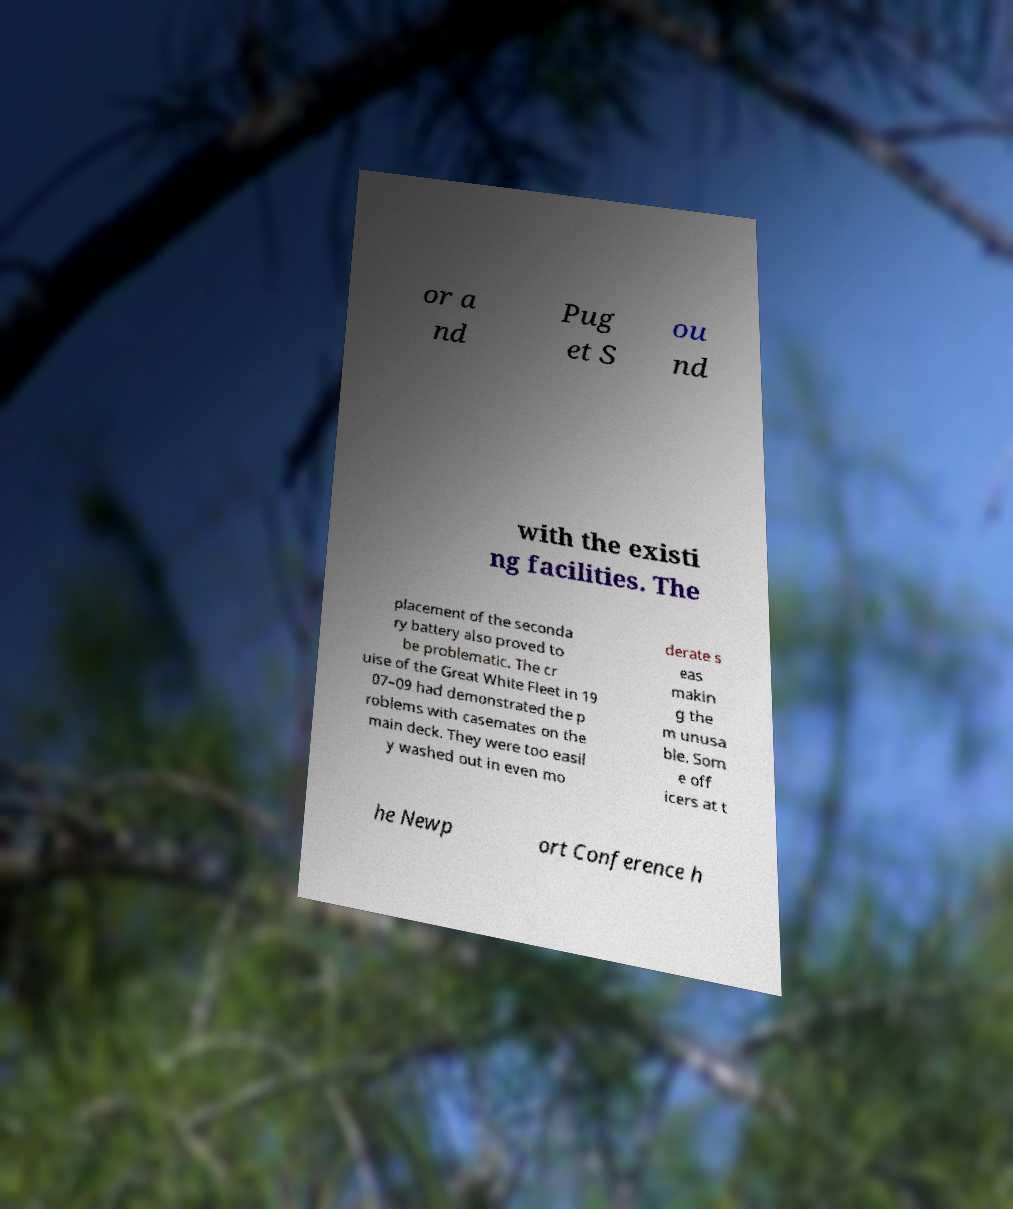I need the written content from this picture converted into text. Can you do that? or a nd Pug et S ou nd with the existi ng facilities. The placement of the seconda ry battery also proved to be problematic. The cr uise of the Great White Fleet in 19 07–09 had demonstrated the p roblems with casemates on the main deck. They were too easil y washed out in even mo derate s eas makin g the m unusa ble. Som e off icers at t he Newp ort Conference h 